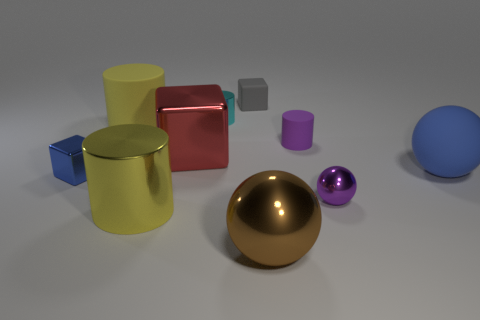What number of large rubber things are both behind the large blue rubber thing and on the right side of the brown metal sphere?
Keep it short and to the point. 0. There is a tiny object that is both behind the blue sphere and on the left side of the rubber cube; what is its material?
Give a very brief answer. Metal. Is the color of the big block the same as the matte cylinder that is on the right side of the small metal cylinder?
Provide a short and direct response. No. There is a yellow metal thing that is the same shape as the yellow matte thing; what size is it?
Offer a very short reply. Large. There is a matte object that is both on the left side of the large metal sphere and right of the large red block; what is its shape?
Keep it short and to the point. Cube. Is the size of the blue matte thing the same as the yellow cylinder that is behind the tiny metallic cube?
Provide a short and direct response. Yes. The other small object that is the same shape as the small blue object is what color?
Keep it short and to the point. Gray. Does the purple object that is behind the tiny shiny sphere have the same size as the rubber object that is left of the small cyan metal object?
Provide a succinct answer. No. Does the cyan object have the same shape as the big red metallic object?
Give a very brief answer. No. What number of things are tiny metal things that are behind the blue matte ball or cyan cylinders?
Provide a short and direct response. 1. 